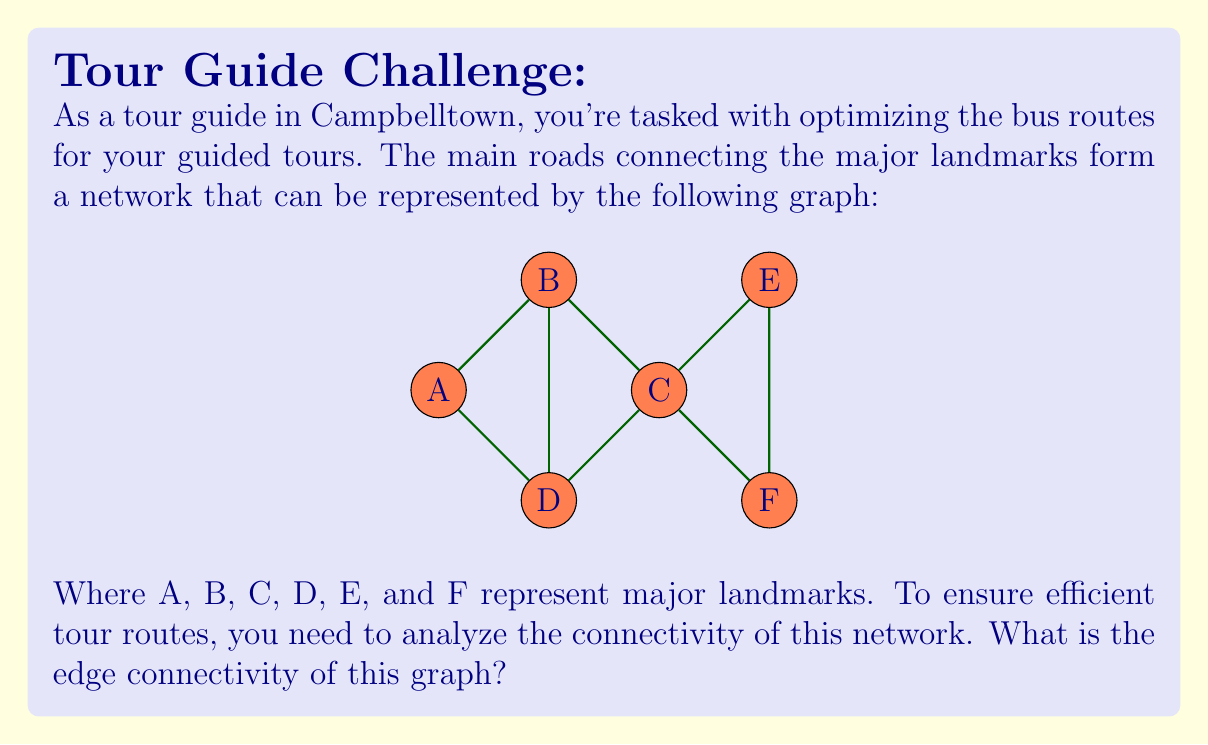Can you solve this math problem? To find the edge connectivity of the graph, we need to determine the minimum number of edges that need to be removed to disconnect the graph. Let's approach this step-by-step:

1) First, let's recall that the edge connectivity is always less than or equal to the minimum degree of the graph.

2) Examining the graph:
   - Vertex A has degree 3
   - Vertex B has degree 3
   - Vertex C has degree 4
   - Vertex D has degree 3
   - Vertices E and F each have degree 2

3) The minimum degree of the graph is 2, so the edge connectivity is at most 2.

4) Now, let's consider if removing any single edge would disconnect the graph. We can see that removing any single edge still leaves a path between all pairs of vertices. So the edge connectivity is at least 2.

5) Next, we need to check if there exists a set of 2 edges whose removal would disconnect the graph.

6) We can see that removing the edges CE and CF would disconnect vertices E and F from the rest of the graph.

7) Therefore, the minimum number of edges that need to be removed to disconnect the graph is 2.

This means the edge connectivity of the graph is 2.
Answer: 2 